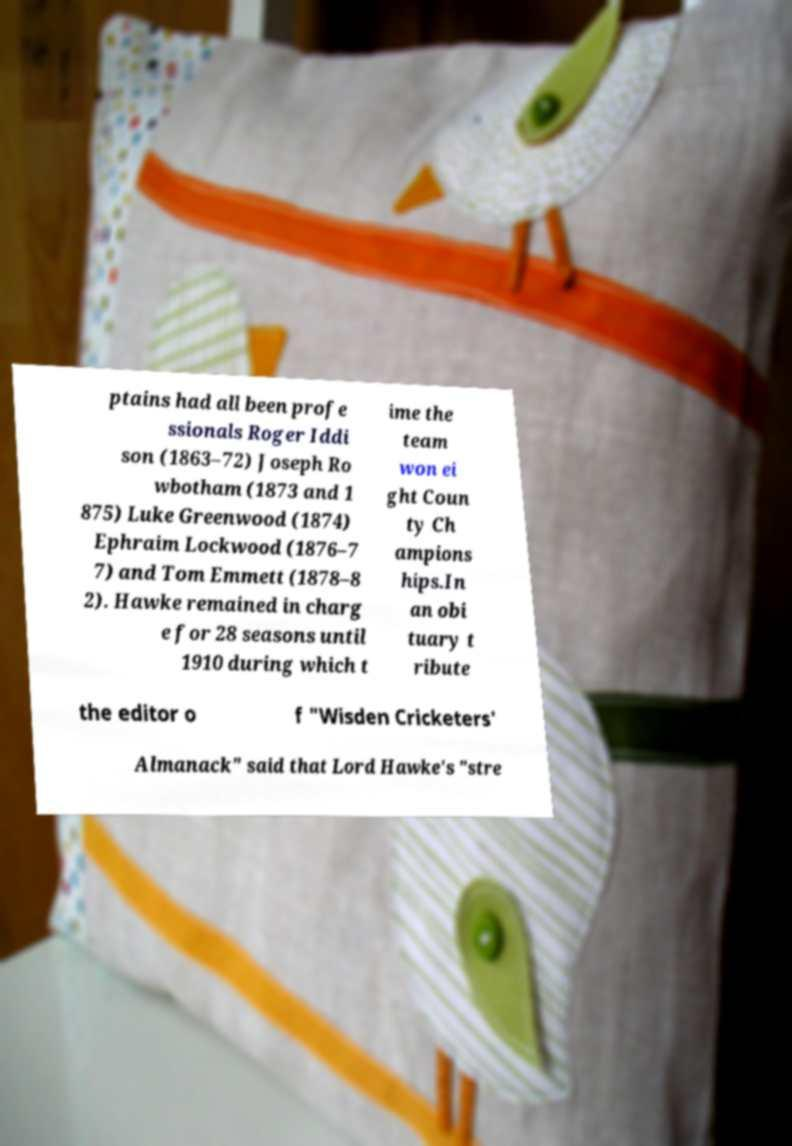Can you accurately transcribe the text from the provided image for me? ptains had all been profe ssionals Roger Iddi son (1863–72) Joseph Ro wbotham (1873 and 1 875) Luke Greenwood (1874) Ephraim Lockwood (1876–7 7) and Tom Emmett (1878–8 2). Hawke remained in charg e for 28 seasons until 1910 during which t ime the team won ei ght Coun ty Ch ampions hips.In an obi tuary t ribute the editor o f "Wisden Cricketers' Almanack" said that Lord Hawke's "stre 